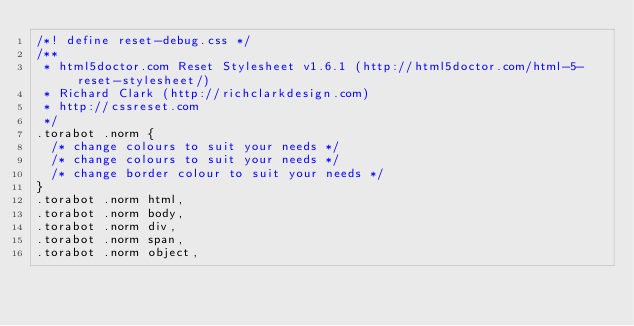Convert code to text. <code><loc_0><loc_0><loc_500><loc_500><_CSS_>/*! define reset-debug.css */
/**
 * html5doctor.com Reset Stylesheet v1.6.1 (http://html5doctor.com/html-5-reset-stylesheet/)
 * Richard Clark (http://richclarkdesign.com)
 * http://cssreset.com
 */
.torabot .norm {
  /* change colours to suit your needs */
  /* change colours to suit your needs */
  /* change border colour to suit your needs */
}
.torabot .norm html,
.torabot .norm body,
.torabot .norm div,
.torabot .norm span,
.torabot .norm object,</code> 